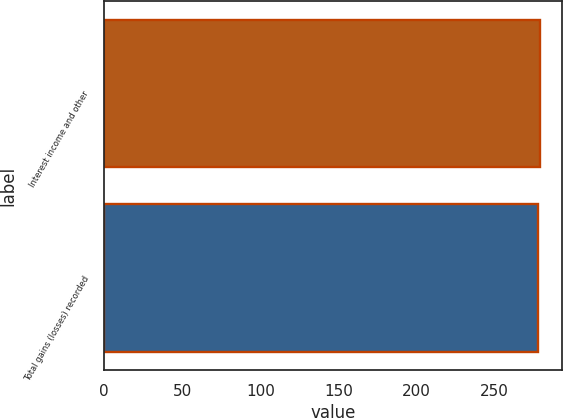Convert chart to OTSL. <chart><loc_0><loc_0><loc_500><loc_500><bar_chart><fcel>Interest income and other<fcel>Total gains (losses) recorded<nl><fcel>279<fcel>278<nl></chart> 